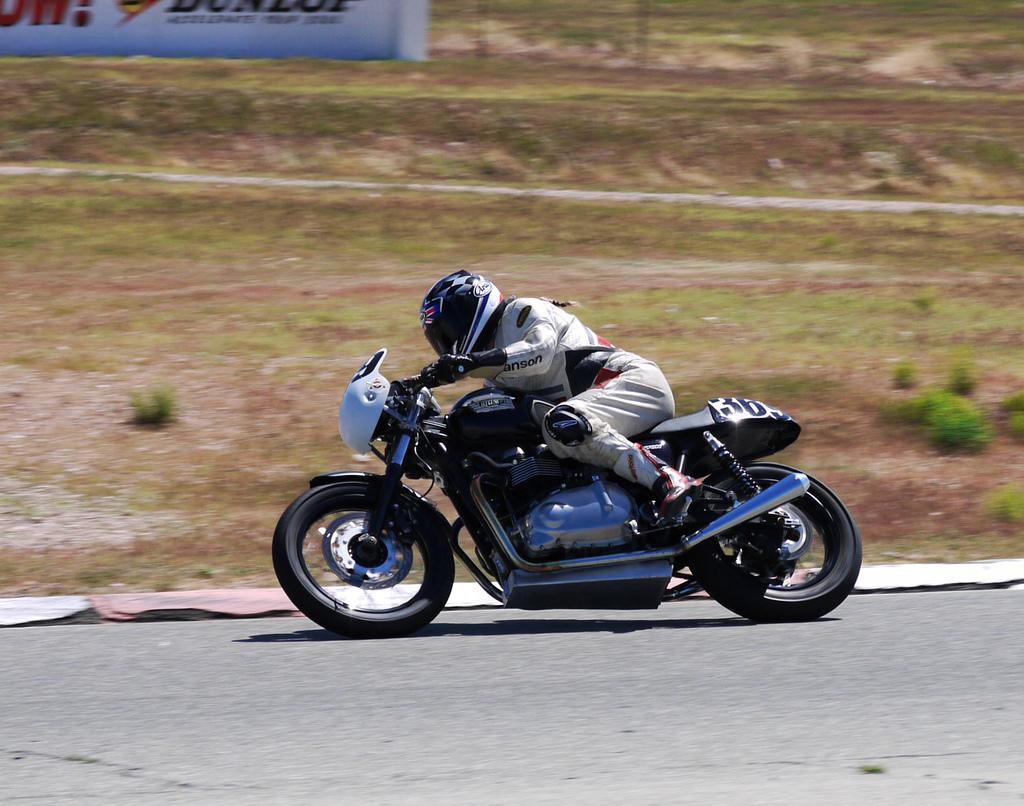Describe this image in one or two sentences. In this image we can see a person driving a motor vehicle on the road. We can also see some plants, grass and a board with some text on it. 